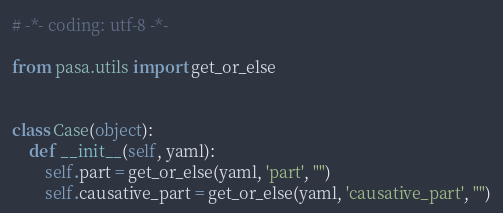Convert code to text. <code><loc_0><loc_0><loc_500><loc_500><_Python_># -*- coding: utf-8 -*-

from pasa.utils import get_or_else


class Case(object):
    def __init__(self, yaml):
        self.part = get_or_else(yaml, 'part', "")
        self.causative_part = get_or_else(yaml, 'causative_part', "")</code> 